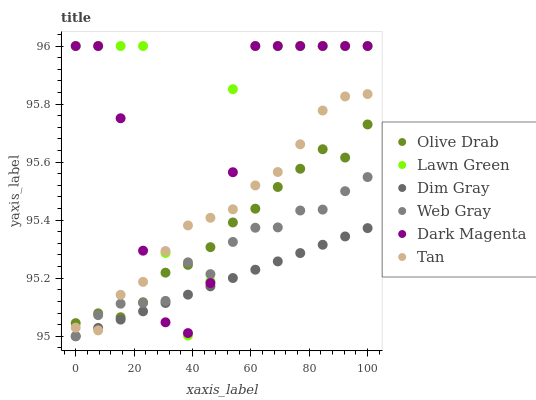Does Dim Gray have the minimum area under the curve?
Answer yes or no. Yes. Does Lawn Green have the maximum area under the curve?
Answer yes or no. Yes. Does Dark Magenta have the minimum area under the curve?
Answer yes or no. No. Does Dark Magenta have the maximum area under the curve?
Answer yes or no. No. Is Dim Gray the smoothest?
Answer yes or no. Yes. Is Lawn Green the roughest?
Answer yes or no. Yes. Is Dark Magenta the smoothest?
Answer yes or no. No. Is Dark Magenta the roughest?
Answer yes or no. No. Does Dim Gray have the lowest value?
Answer yes or no. Yes. Does Dark Magenta have the lowest value?
Answer yes or no. No. Does Dark Magenta have the highest value?
Answer yes or no. Yes. Does Dim Gray have the highest value?
Answer yes or no. No. Is Dim Gray less than Olive Drab?
Answer yes or no. Yes. Is Olive Drab greater than Dim Gray?
Answer yes or no. Yes. Does Dark Magenta intersect Dim Gray?
Answer yes or no. Yes. Is Dark Magenta less than Dim Gray?
Answer yes or no. No. Is Dark Magenta greater than Dim Gray?
Answer yes or no. No. Does Dim Gray intersect Olive Drab?
Answer yes or no. No. 